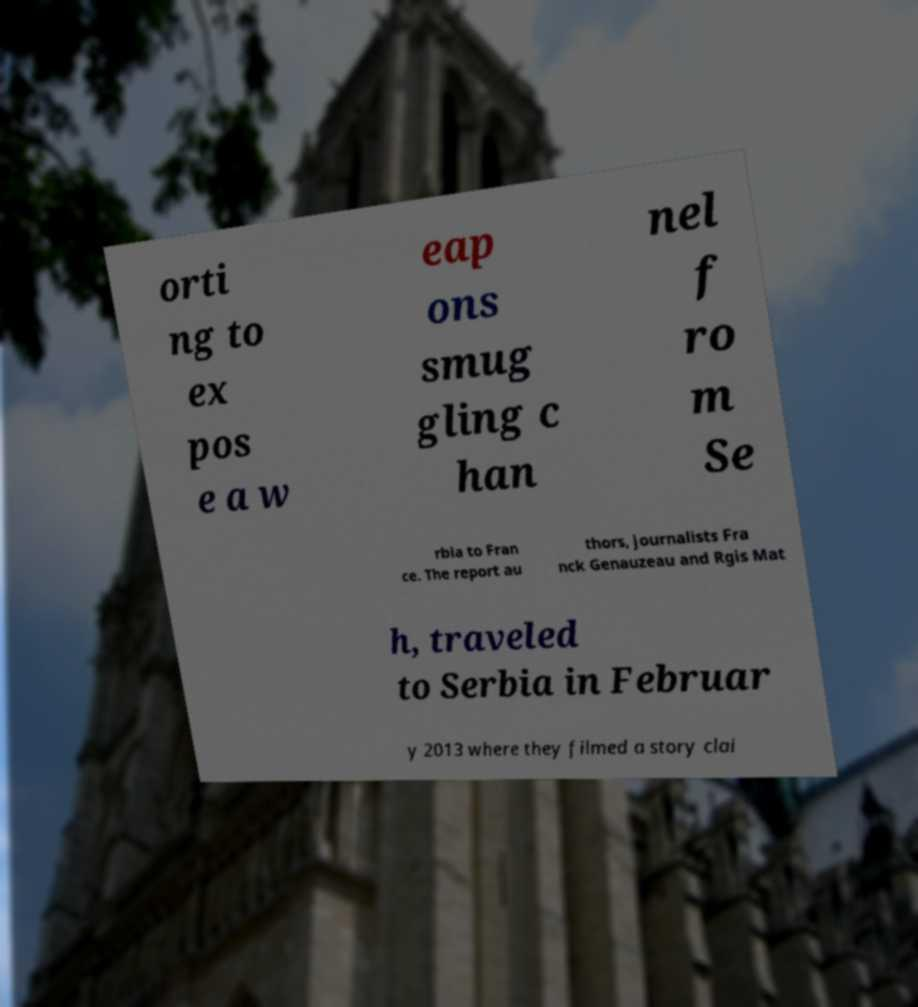Could you extract and type out the text from this image? orti ng to ex pos e a w eap ons smug gling c han nel f ro m Se rbia to Fran ce. The report au thors, journalists Fra nck Genauzeau and Rgis Mat h, traveled to Serbia in Februar y 2013 where they filmed a story clai 